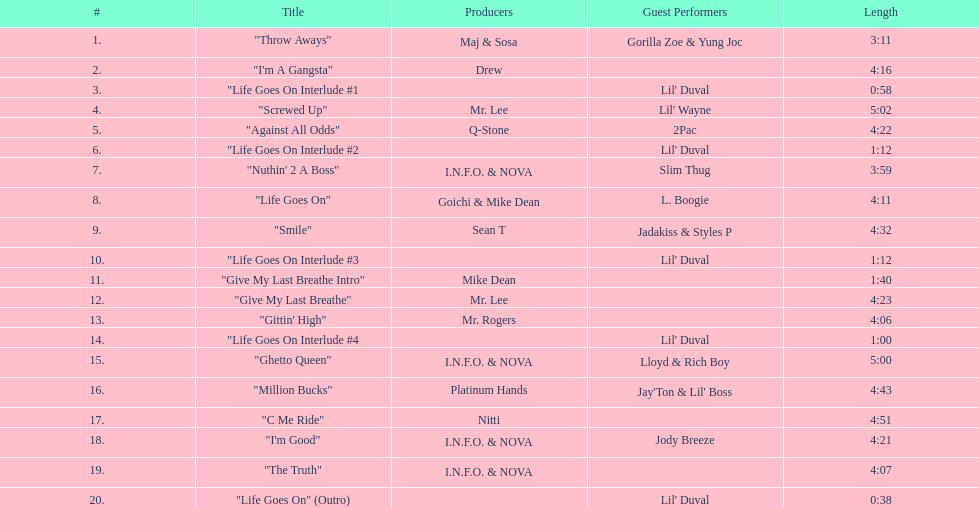How long is the longest track on the album? 5:02. 